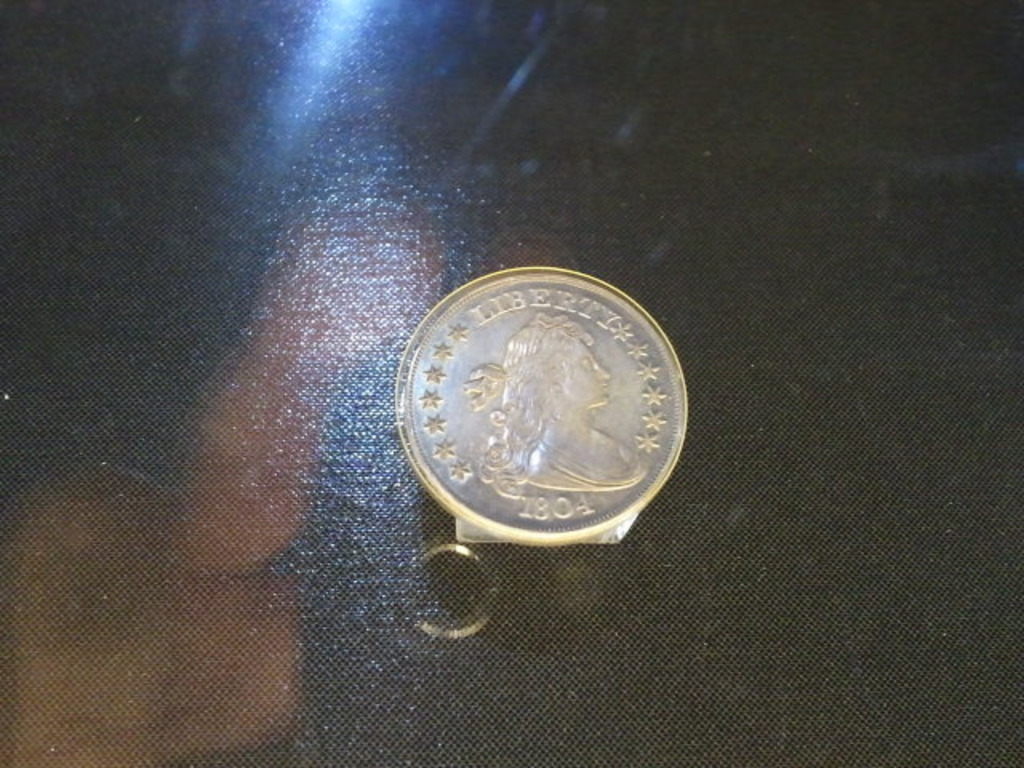Provide a one-sentence caption for the provided image.
Reference OCR token: 1801 A silver Liberty coin from 1804 on a table. 